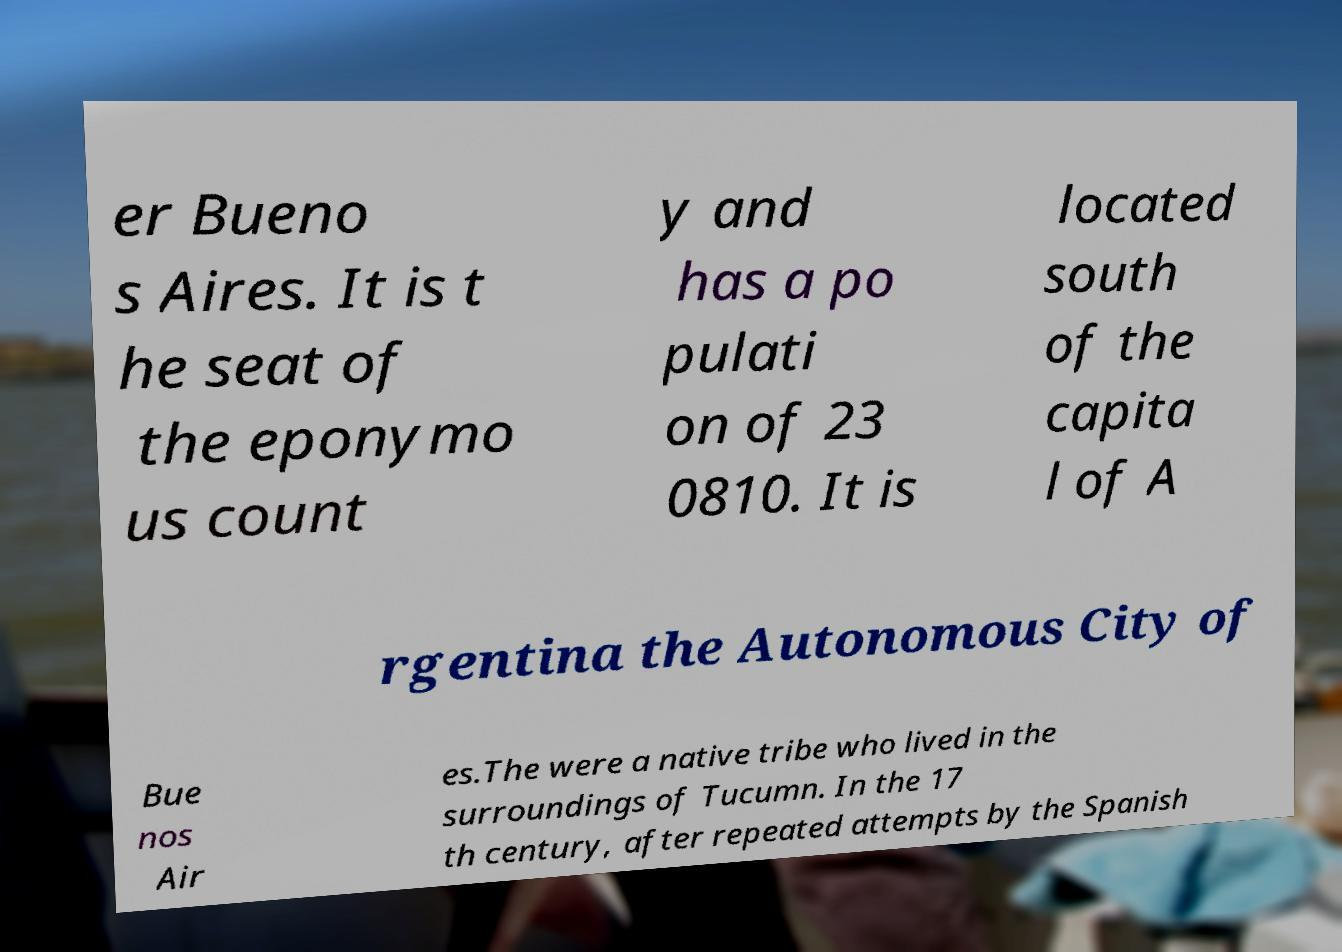Could you extract and type out the text from this image? er Bueno s Aires. It is t he seat of the eponymo us count y and has a po pulati on of 23 0810. It is located south of the capita l of A rgentina the Autonomous City of Bue nos Air es.The were a native tribe who lived in the surroundings of Tucumn. In the 17 th century, after repeated attempts by the Spanish 